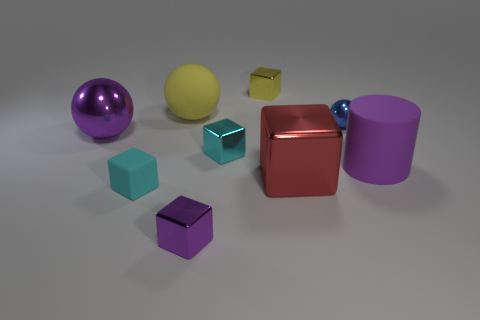Subtract all small cyan metallic blocks. How many blocks are left? 4 Subtract all purple cubes. How many cubes are left? 4 Subtract 2 blocks. How many blocks are left? 3 Subtract all blue blocks. Subtract all brown cylinders. How many blocks are left? 5 Add 1 large brown balls. How many objects exist? 10 Subtract all cubes. How many objects are left? 4 Add 1 yellow rubber objects. How many yellow rubber objects are left? 2 Add 5 big brown metal cylinders. How many big brown metal cylinders exist? 5 Subtract 0 cyan spheres. How many objects are left? 9 Subtract all big red balls. Subtract all yellow cubes. How many objects are left? 8 